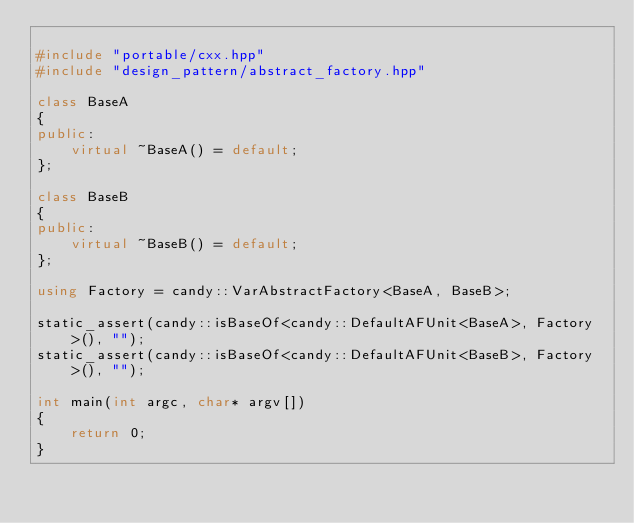Convert code to text. <code><loc_0><loc_0><loc_500><loc_500><_C++_>
#include "portable/cxx.hpp"
#include "design_pattern/abstract_factory.hpp"

class BaseA
{
public:
    virtual ~BaseA() = default;
};

class BaseB
{
public:
    virtual ~BaseB() = default;
};

using Factory = candy::VarAbstractFactory<BaseA, BaseB>;

static_assert(candy::isBaseOf<candy::DefaultAFUnit<BaseA>, Factory>(), "");
static_assert(candy::isBaseOf<candy::DefaultAFUnit<BaseB>, Factory>(), "");

int main(int argc, char* argv[])
{
    return 0;
}
</code> 